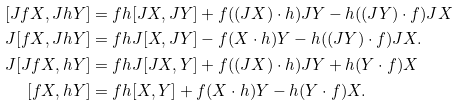Convert formula to latex. <formula><loc_0><loc_0><loc_500><loc_500>[ J f X , J h Y ] & = f h [ J X , J Y ] + f ( ( J X ) \cdot h ) J Y - h ( ( J Y ) \cdot f ) J X \\ J [ f X , J h Y ] & = f h J [ X , J Y ] - f ( X \cdot h ) Y - h ( ( J Y ) \cdot f ) J X . \\ J [ J f X , h Y ] & = f h J [ J X , Y ] + f ( ( J X ) \cdot h ) J Y + h ( Y \cdot f ) X \\ [ f X , h Y ] & = f h [ X , Y ] + f ( X \cdot h ) Y - h ( Y \cdot f ) X .</formula> 